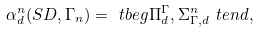Convert formula to latex. <formula><loc_0><loc_0><loc_500><loc_500>\alpha ^ { n } _ { d } ( S D , \Gamma _ { n } ) = \ t b e g \Pi ^ { \Gamma } _ { d } , \Sigma ^ { n } _ { \Gamma , d } \ t e n d ,</formula> 